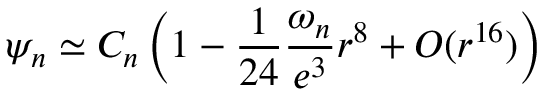Convert formula to latex. <formula><loc_0><loc_0><loc_500><loc_500>\psi _ { n } \simeq C _ { n } \left ( 1 - \frac { 1 } { 2 4 } \frac { \omega _ { n } } { e ^ { 3 } } r ^ { 8 } + O ( r ^ { 1 6 } ) \right )</formula> 